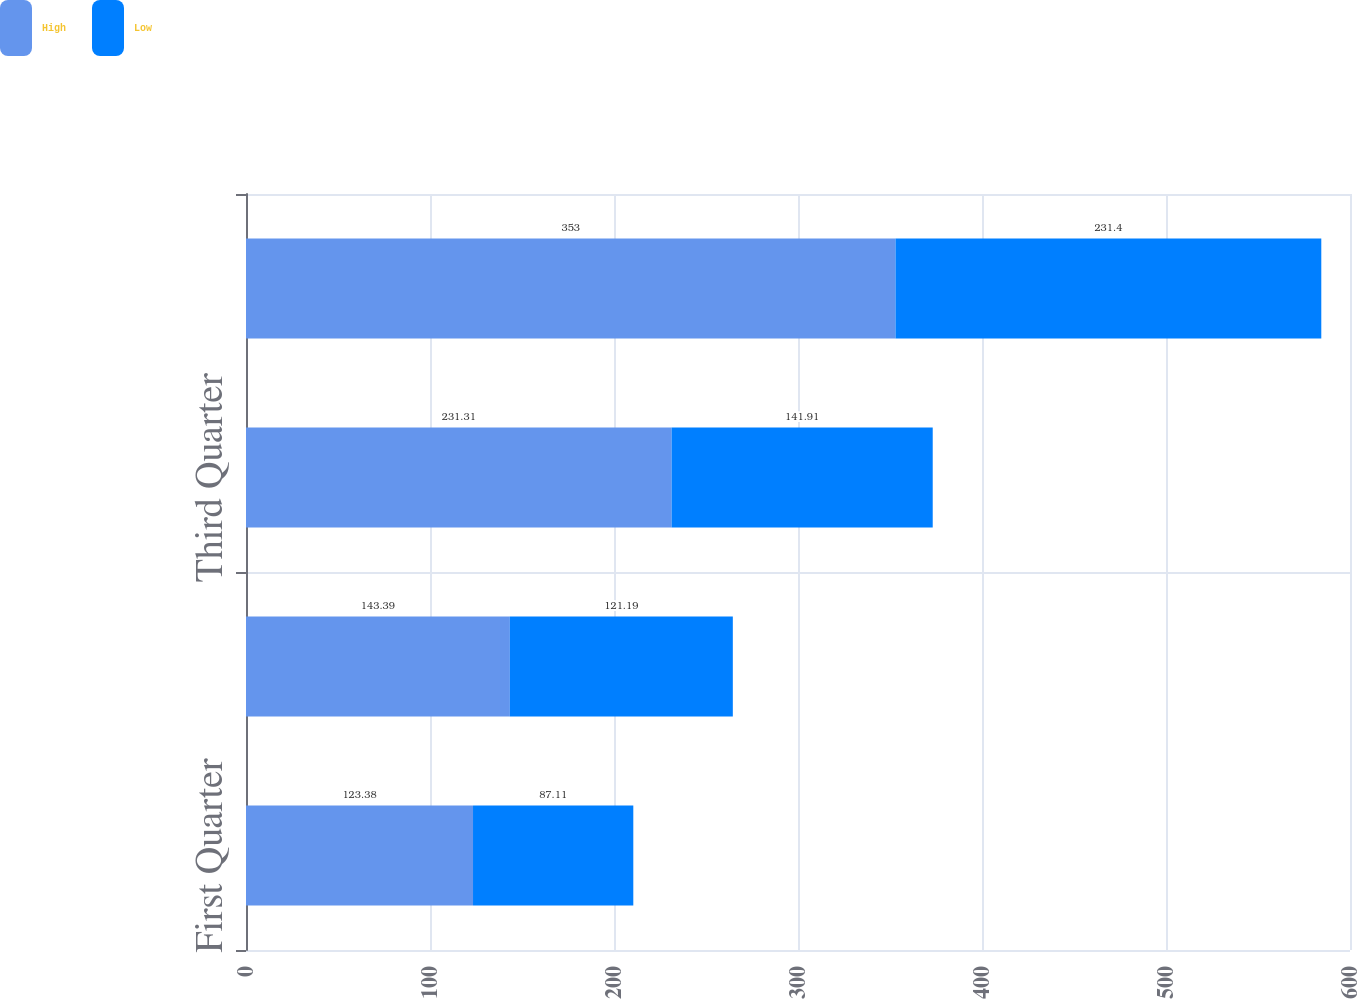Convert chart. <chart><loc_0><loc_0><loc_500><loc_500><stacked_bar_chart><ecel><fcel>First Quarter<fcel>Second Quarter<fcel>Third Quarter<fcel>Fourth Quarter<nl><fcel>High<fcel>123.38<fcel>143.39<fcel>231.31<fcel>353<nl><fcel>Low<fcel>87.11<fcel>121.19<fcel>141.91<fcel>231.4<nl></chart> 